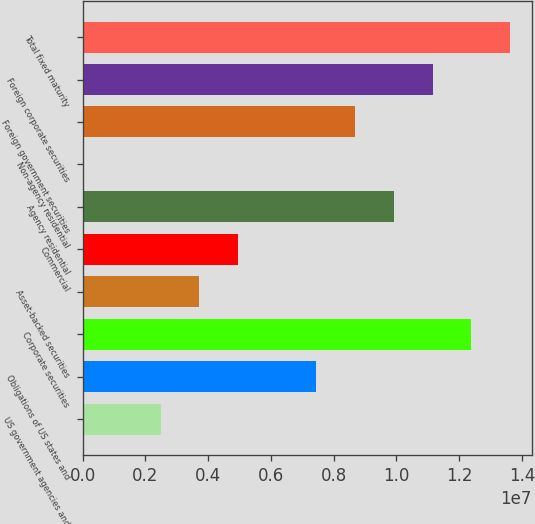<chart> <loc_0><loc_0><loc_500><loc_500><bar_chart><fcel>US government agencies and<fcel>Obligations of US states and<fcel>Corporate securities<fcel>Asset-backed securities<fcel>Commercial<fcel>Agency residential<fcel>Non-agency residential<fcel>Foreign government securities<fcel>Foreign corporate securities<fcel>Total fixed maturity<nl><fcel>2.48209e+06<fcel>7.43662e+06<fcel>1.23912e+07<fcel>3.72072e+06<fcel>4.95936e+06<fcel>9.91389e+06<fcel>4816<fcel>8.67526e+06<fcel>1.11525e+07<fcel>1.36298e+07<nl></chart> 